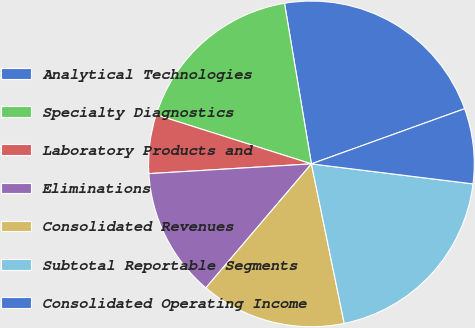Convert chart. <chart><loc_0><loc_0><loc_500><loc_500><pie_chart><fcel>Analytical Technologies<fcel>Specialty Diagnostics<fcel>Laboratory Products and<fcel>Eliminations<fcel>Consolidated Revenues<fcel>Subtotal Reportable Segments<fcel>Consolidated Operating Income<nl><fcel>22.14%<fcel>17.48%<fcel>5.83%<fcel>12.82%<fcel>14.45%<fcel>19.81%<fcel>7.46%<nl></chart> 